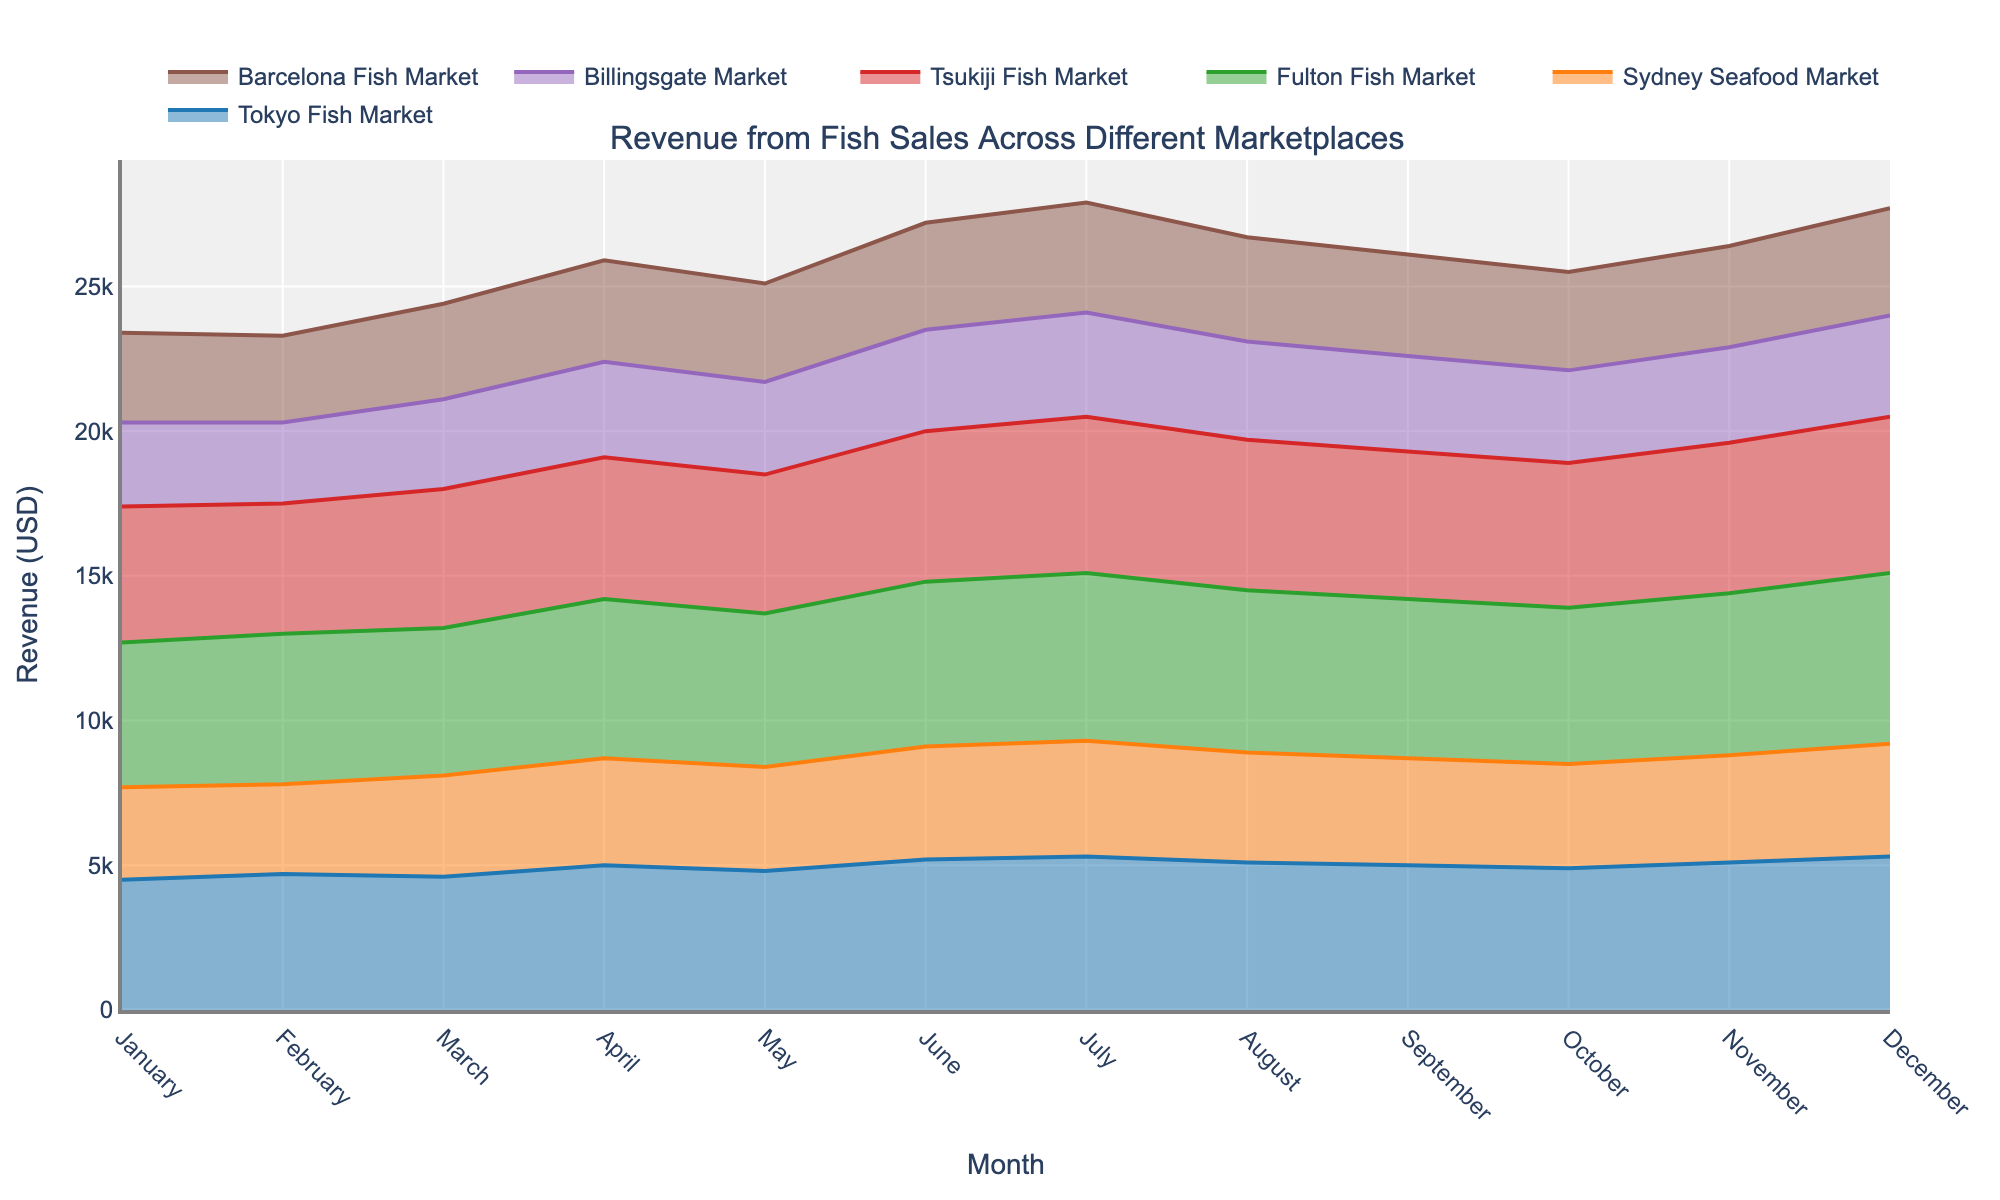What is the title of the chart? The title is usually displayed at the top of the figure. By observing the figure, we can identify the title written there.
Answer: Revenue from Fish Sales Across Different Marketplaces What is the highest monthly revenue for the Billingsgate Market? Look at the line representing the Billingsgate Market and identify the highest point. The y-axis will provide the revenue value for that point.
Answer: 3600 USD Which marketplace shows the most significant increase from January to December? Check the difference between the January and December points for each marketplace. The Tokyo Fish Market increases from 4500 to 5300 (800 USD), Sydney from 3200 to 3900 (700 USD), Fulton from 5000 to 5900 (900 USD), Tsukiji from 4700 to 5400 (700 USD), Billingsgate from 2900 to 3500 (600 USD), and Barcelona from 3100 to 3700 (600 USD).
Answer: Fulton Fish Market How does the revenue trend differ between Sydney Seafood Market and Fulton Fish Market? Observe the trends of the lines for both markets. Notice that the Sydney Seafood Market's line remains relatively lower and less steep compared to the Fulton Fish Market's upward trend.
Answer: Sydney has a steady, modest increase; Fulton has a steep increase In which month do all marketplaces show an upward trend after a dip? Look for a month where all lines increase following a previous decline. After May, in June, all marketplaces experience an upward trend.
Answer: June Which two marketplaces have overlapping revenue trends in most months? Compare the lines for the marketplaces that seem to follow a similar path across multiple months. Tokyo Fish Market and Tsukiji Fish Market have many similar revenue levels over most months.
Answer: Tokyo Fish Market and Tsukiji Fish Market What is the average revenue for the Barcelona Fish Market over the year? Calculate the sum of the monthly revenues and divide by the number of months. (3100+3000+3300+3500+3400+3700+3800+3600+3500+3400+3500+3700) / 12 = 3600
Answer: 3600 USD Which marketplace's revenue remained the most steady throughout the year? Analyze which line has the least fluctuation in values throughout the months. Barcelona Fish Market has a relatively stable revenue compared to the others.
Answer: Barcelona Fish Market If you sum the revenues of all marketplaces in February, what is the value? Add the February revenue for each marketplace: 4700 (Tokyo) + 3100 (Sydney) + 5200 (Fulton) + 4500 (Tsukiji) + 2800 (Billingsgate) + 3000 (Barcelona) = 23300 USD
Answer: 23300 USD Which month has the highest overall revenue when combined for all marketplaces? Sum the revenue for all marketplaces for each month and compare. December: 5300 (Tokyo) + 3900 (Sydney) + 5900 (Fulton) + 5400 (Tsukiji) + 3500 (Billingsgate) + 3700 (Barcelona) = 27700 USD
Answer: December 